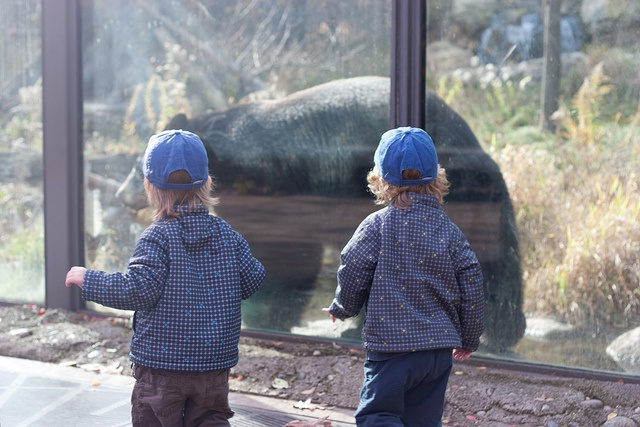Describe the objects in this image and their specific colors. I can see bear in darkgray, gray, and black tones, people in darkgray, navy, gray, and black tones, and people in darkgray, purple, navy, gray, and darkblue tones in this image. 